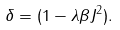<formula> <loc_0><loc_0><loc_500><loc_500>\delta = ( 1 - \lambda \beta J ^ { 2 } ) .</formula> 